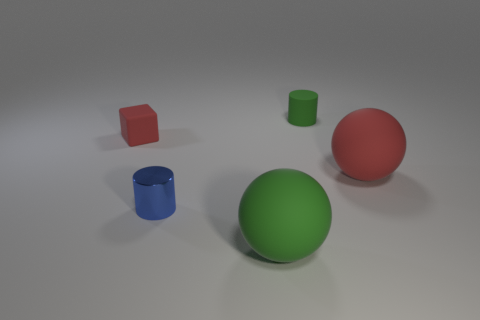Are there any things of the same color as the cube?
Make the answer very short. Yes. The small object that is to the left of the tiny blue thing is what color?
Your answer should be very brief. Red. There is a big matte thing behind the green matte ball; is it the same color as the shiny cylinder?
Your response must be concise. No. What is the material of the big red thing that is the same shape as the big green object?
Make the answer very short. Rubber. What number of green objects have the same size as the green matte cylinder?
Provide a short and direct response. 0. The big red thing is what shape?
Your response must be concise. Sphere. There is a rubber object that is behind the small metal object and on the left side of the matte cylinder; what size is it?
Make the answer very short. Small. What is the material of the ball that is in front of the tiny blue thing?
Your answer should be compact. Rubber. Do the tiny matte cylinder and the large matte sphere in front of the tiny blue cylinder have the same color?
Provide a succinct answer. Yes. What number of objects are either small rubber things that are to the right of the tiny red matte thing or red objects behind the big red matte ball?
Your response must be concise. 2. 